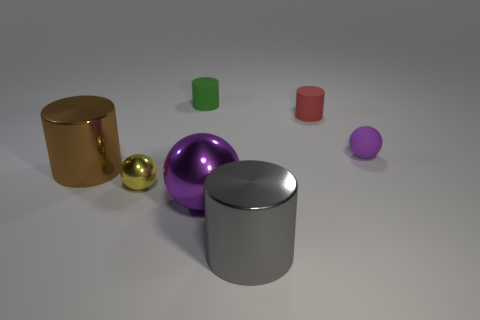The small sphere in front of the tiny ball to the right of the red matte cylinder is what color? The small sphere located in front of the tiny ball and to the right of the red matte cylinder displays a striking yellow hue. 